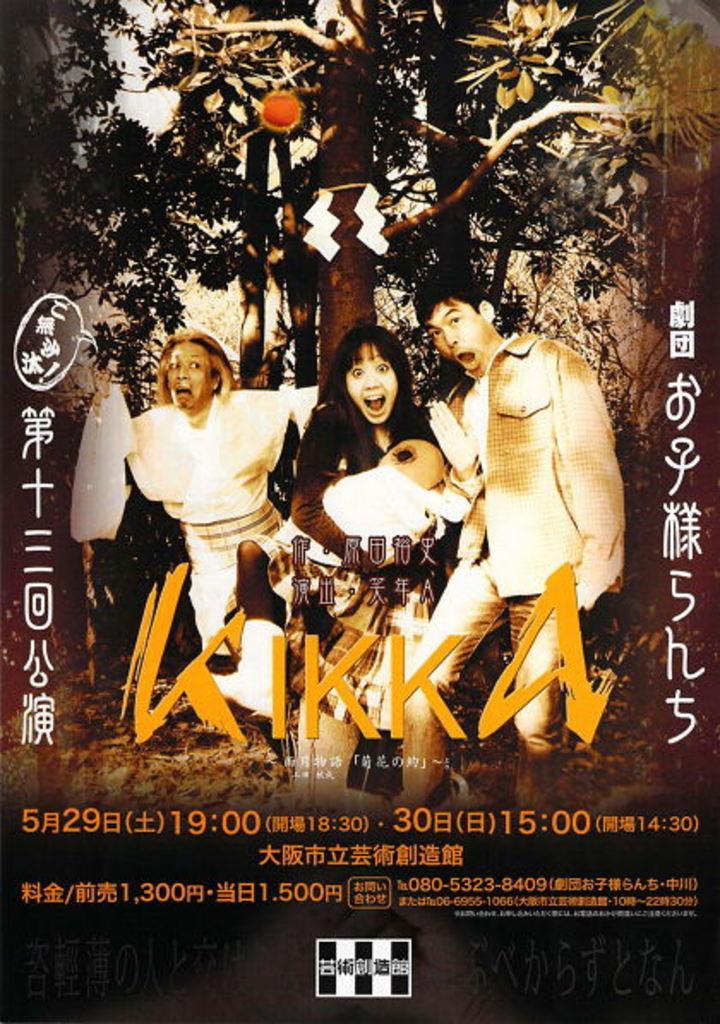How would you summarize this image in a sentence or two? In this image we can see an advertisement. 